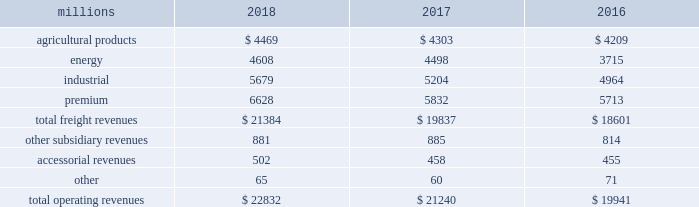Notes to the consolidated financial statements union pacific corporation and subsidiary companies for purposes of this report , unless the context otherwise requires , all references herein to the 201ccorporation 201d , 201ccompany 201d , 201cupc 201d , 201cwe 201d , 201cus 201d , and 201cour 201d mean union pacific corporation and its subsidiaries , including union pacific railroad company , which will be separately referred to herein as 201cuprr 201d or the 201crailroad 201d .
Nature of operations operations and segmentation 2013 we are a class i railroad operating in the u.s .
Our network includes 32236 route miles , linking pacific coast and gulf coast ports with the midwest and eastern u.s .
Gateways and providing several corridors to key mexican gateways .
We own 26039 miles and operate on the remainder pursuant to trackage rights or leases .
We serve the western two-thirds of the country and maintain coordinated schedules with other rail carriers for the handling of freight to and from the atlantic coast , the pacific coast , the southeast , the southwest , canada , and mexico .
Export and import traffic is moved through gulf coast and pacific coast ports and across the mexican and canadian borders .
The railroad , along with its subsidiaries and rail affiliates , is our one reportable operating segment .
Although we provide and analyze revenue by commodity group , we treat the financial results of the railroad as one segment due to the integrated nature of our rail network .
Our operating revenues are primarily derived from contracts with customers for the transportation of freight from origin to destination .
Effective january 1 , 2018 , the company reclassified its six commodity groups into four : agricultural products , energy , industrial , and premium .
The table represents a disaggregation of our freight and other revenues: .
Although our revenues are principally derived from customers domiciled in the u.s. , the ultimate points of origination or destination for some products we transport are outside the u.s .
Each of our commodity groups includes revenue from shipments to and from mexico .
Included in the above table are freight revenues from our mexico business which amounted to $ 2.5 billion in 2018 , $ 2.3 billion in 2017 , and $ 2.2 billion in 2016 .
Basis of presentation 2013 the consolidated financial statements are presented in accordance with accounting principles generally accepted in the u.s .
( gaap ) as codified in the financial accounting standards board ( fasb ) accounting standards codification ( asc ) .
Significant accounting policies principles of consolidation 2013 the consolidated financial statements include the accounts of union pacific corporation and all of its subsidiaries .
Investments in affiliated companies ( 20% ( 20 % ) to 50% ( 50 % ) owned ) are accounted for using the equity method of accounting .
All intercompany transactions are eliminated .
We currently have no less than majority-owned investments that require consolidation under variable interest entity requirements .
Cash , cash equivalents and restricted cash 2013 cash equivalents consist of investments with original maturities of three months or less .
Amounts included in restricted cash represent those required to be set aside by contractual agreement. .
In billions , what would 2018 total operating revenues have been without the mexico business? 
Computations: ((22832 / 1000) - 2.5)
Answer: 20.332. 